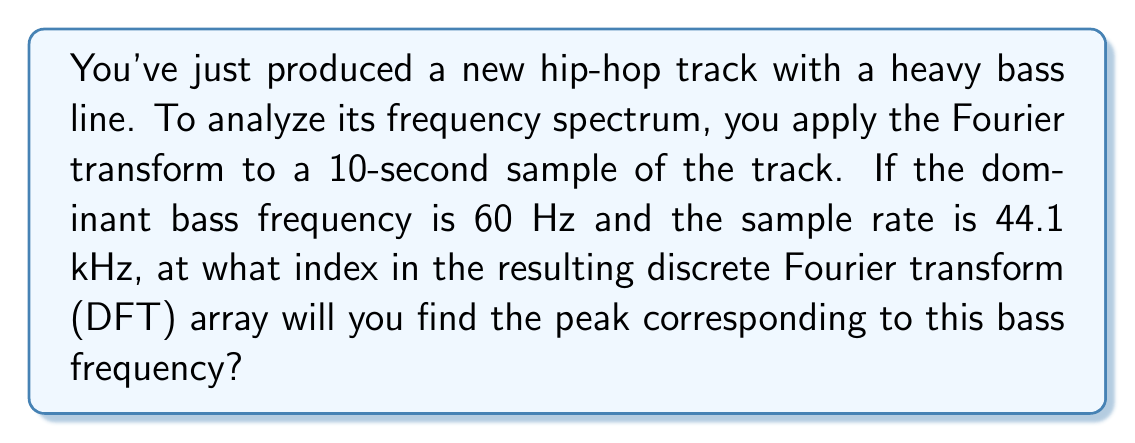Could you help me with this problem? To solve this problem, we'll follow these steps:

1) First, we need to determine the number of samples in our 10-second clip:
   $N = \text{sample rate} \times \text{duration}$
   $N = 44100 \text{ Hz} \times 10 \text{ s} = 441000 \text{ samples}$

2) In a DFT, the frequency resolution is given by:
   $\Delta f = \frac{\text{sample rate}}{N} = \frac{44100}{441000} = 0.1 \text{ Hz}$

3) The frequency bins in the DFT are spaced at intervals of $\Delta f$. To find the index $k$ of a particular frequency $f$, we use:
   $k = \frac{f}{\Delta f}$

4) For our bass frequency of 60 Hz:
   $k = \frac{60 \text{ Hz}}{0.1 \text{ Hz/bin}} = 600$

Therefore, the peak corresponding to the 60 Hz bass frequency will be found at index 600 in the DFT array.

Note: In practice, you would typically use a Fast Fourier Transform (FFT) algorithm to compute the DFT efficiently. The result would be the same, but the computation would be much faster, especially for a hip-hop producer working with long audio samples.
Answer: 600 